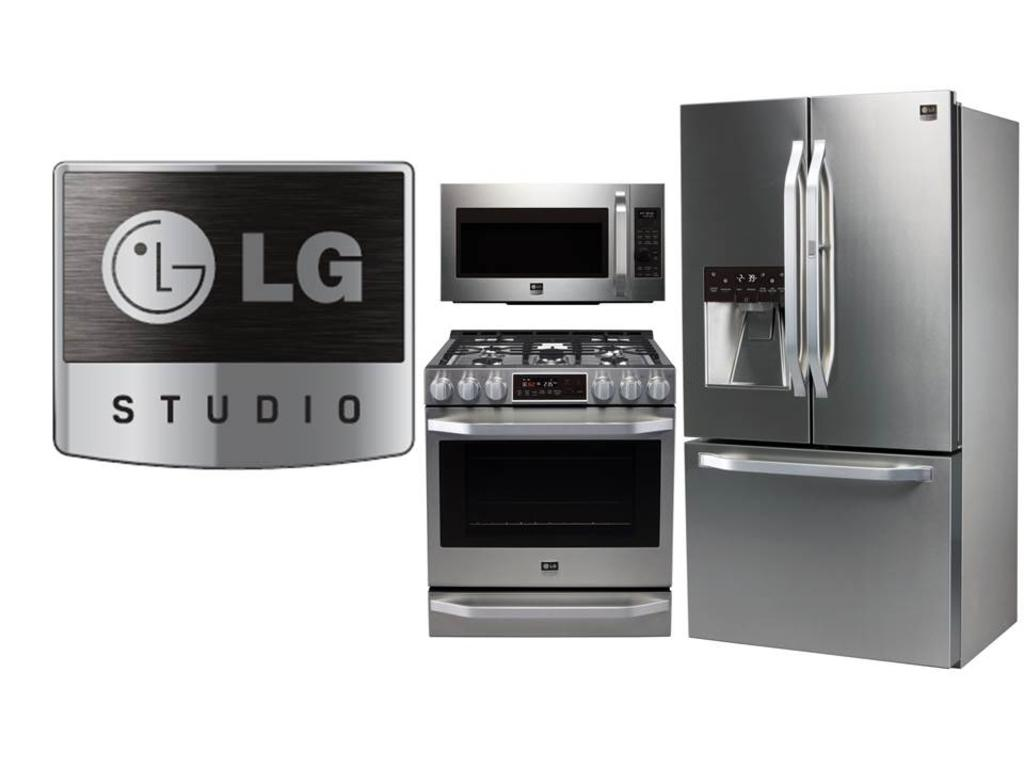<image>
Present a compact description of the photo's key features. A collection of kitchen appliances and a logo from LG are on display. 